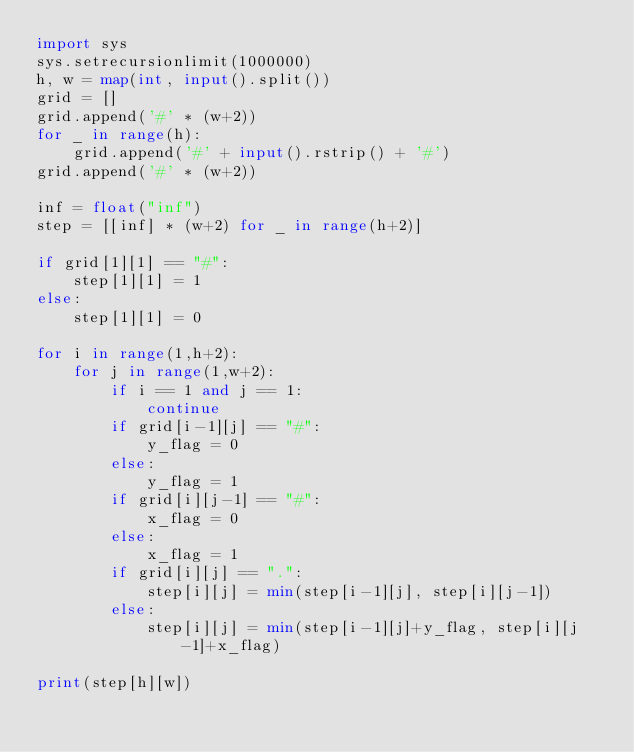<code> <loc_0><loc_0><loc_500><loc_500><_Python_>import sys
sys.setrecursionlimit(1000000)
h, w = map(int, input().split())
grid = []
grid.append('#' * (w+2))
for _ in range(h):
    grid.append('#' + input().rstrip() + '#')
grid.append('#' * (w+2))
             
inf = float("inf")
step = [[inf] * (w+2) for _ in range(h+2)]

if grid[1][1] == "#":
    step[1][1] = 1
else:
    step[1][1] = 0
    
for i in range(1,h+2):
    for j in range(1,w+2):
        if i == 1 and j == 1:
            continue
        if grid[i-1][j] == "#":
            y_flag = 0
        else:
            y_flag = 1 
        if grid[i][j-1] == "#":
            x_flag = 0
        else:
            x_flag = 1
        if grid[i][j] == ".":
            step[i][j] = min(step[i-1][j], step[i][j-1])
        else:
            step[i][j] = min(step[i-1][j]+y_flag, step[i][j-1]+x_flag)

print(step[h][w])</code> 